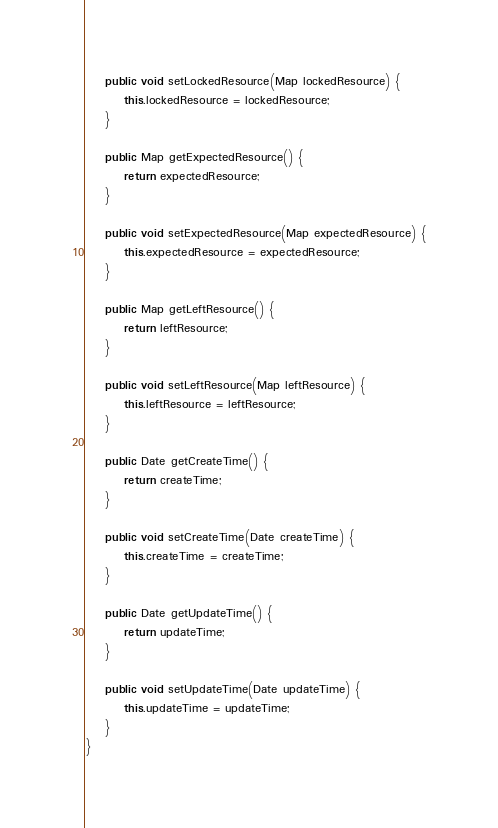<code> <loc_0><loc_0><loc_500><loc_500><_Java_>    public void setLockedResource(Map lockedResource) {
        this.lockedResource = lockedResource;
    }

    public Map getExpectedResource() {
        return expectedResource;
    }

    public void setExpectedResource(Map expectedResource) {
        this.expectedResource = expectedResource;
    }

    public Map getLeftResource() {
        return leftResource;
    }

    public void setLeftResource(Map leftResource) {
        this.leftResource = leftResource;
    }

    public Date getCreateTime() {
        return createTime;
    }

    public void setCreateTime(Date createTime) {
        this.createTime = createTime;
    }

    public Date getUpdateTime() {
        return updateTime;
    }

    public void setUpdateTime(Date updateTime) {
        this.updateTime = updateTime;
    }
}
</code> 